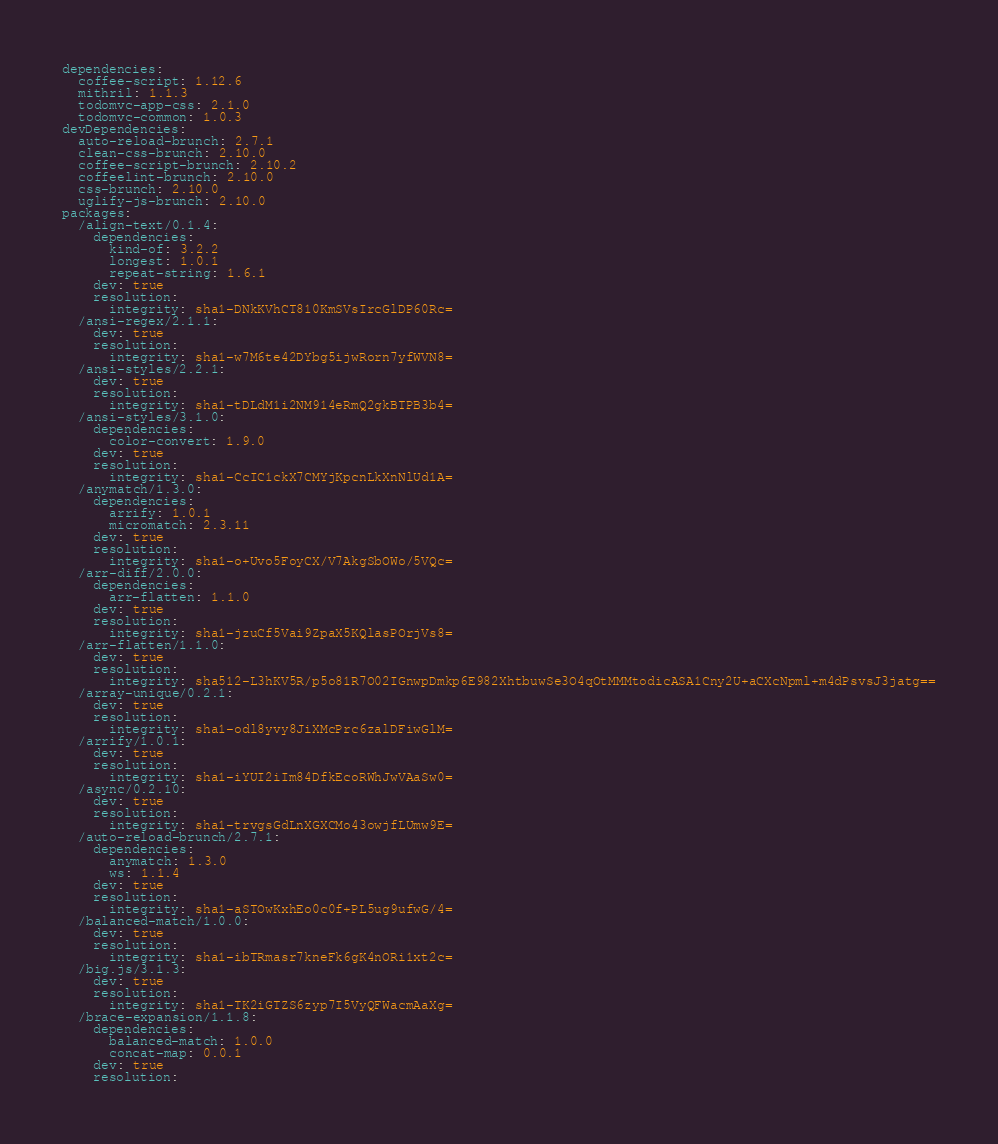<code> <loc_0><loc_0><loc_500><loc_500><_YAML_>dependencies:
  coffee-script: 1.12.6
  mithril: 1.1.3
  todomvc-app-css: 2.1.0
  todomvc-common: 1.0.3
devDependencies:
  auto-reload-brunch: 2.7.1
  clean-css-brunch: 2.10.0
  coffee-script-brunch: 2.10.2
  coffeelint-brunch: 2.10.0
  css-brunch: 2.10.0
  uglify-js-brunch: 2.10.0
packages:
  /align-text/0.1.4:
    dependencies:
      kind-of: 3.2.2
      longest: 1.0.1
      repeat-string: 1.6.1
    dev: true
    resolution:
      integrity: sha1-DNkKVhCT810KmSVsIrcGlDP60Rc=
  /ansi-regex/2.1.1:
    dev: true
    resolution:
      integrity: sha1-w7M6te42DYbg5ijwRorn7yfWVN8=
  /ansi-styles/2.2.1:
    dev: true
    resolution:
      integrity: sha1-tDLdM1i2NM914eRmQ2gkBTPB3b4=
  /ansi-styles/3.1.0:
    dependencies:
      color-convert: 1.9.0
    dev: true
    resolution:
      integrity: sha1-CcIC1ckX7CMYjKpcnLkXnNlUd1A=
  /anymatch/1.3.0:
    dependencies:
      arrify: 1.0.1
      micromatch: 2.3.11
    dev: true
    resolution:
      integrity: sha1-o+Uvo5FoyCX/V7AkgSbOWo/5VQc=
  /arr-diff/2.0.0:
    dependencies:
      arr-flatten: 1.1.0
    dev: true
    resolution:
      integrity: sha1-jzuCf5Vai9ZpaX5KQlasPOrjVs8=
  /arr-flatten/1.1.0:
    dev: true
    resolution:
      integrity: sha512-L3hKV5R/p5o81R7O02IGnwpDmkp6E982XhtbuwSe3O4qOtMMMtodicASA1Cny2U+aCXcNpml+m4dPsvsJ3jatg==
  /array-unique/0.2.1:
    dev: true
    resolution:
      integrity: sha1-odl8yvy8JiXMcPrc6zalDFiwGlM=
  /arrify/1.0.1:
    dev: true
    resolution:
      integrity: sha1-iYUI2iIm84DfkEcoRWhJwVAaSw0=
  /async/0.2.10:
    dev: true
    resolution:
      integrity: sha1-trvgsGdLnXGXCMo43owjfLUmw9E=
  /auto-reload-brunch/2.7.1:
    dependencies:
      anymatch: 1.3.0
      ws: 1.1.4
    dev: true
    resolution:
      integrity: sha1-aSTOwKxhEo0c0f+PL5ug9ufwG/4=
  /balanced-match/1.0.0:
    dev: true
    resolution:
      integrity: sha1-ibTRmasr7kneFk6gK4nORi1xt2c=
  /big.js/3.1.3:
    dev: true
    resolution:
      integrity: sha1-TK2iGTZS6zyp7I5VyQFWacmAaXg=
  /brace-expansion/1.1.8:
    dependencies:
      balanced-match: 1.0.0
      concat-map: 0.0.1
    dev: true
    resolution:</code> 